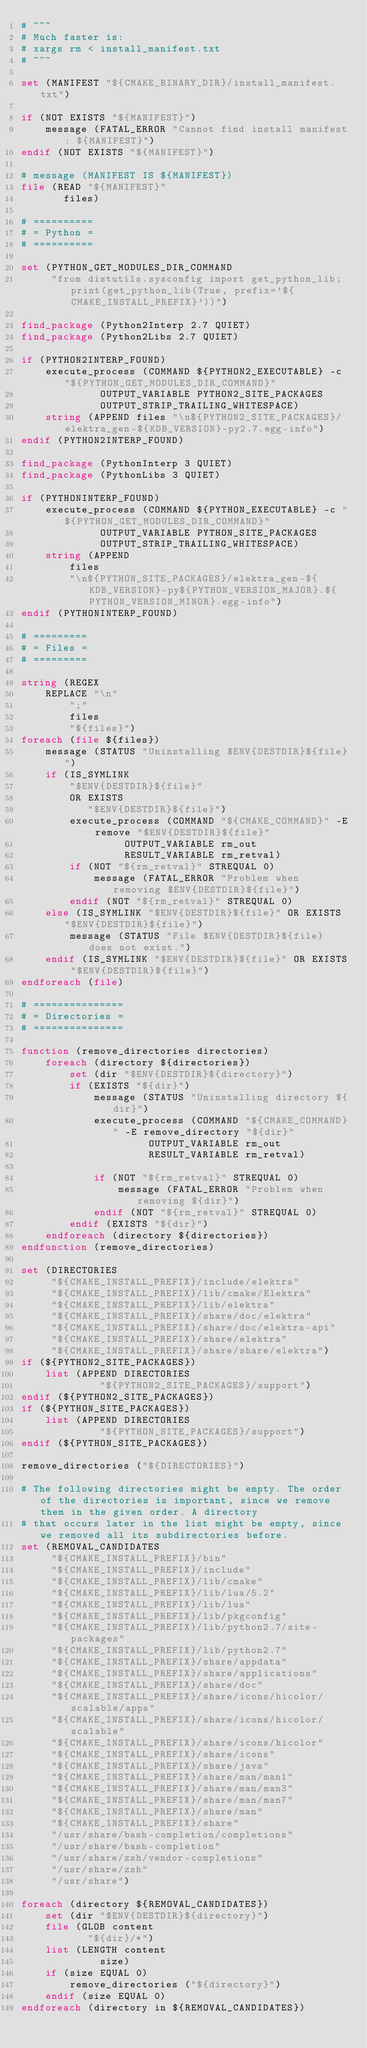<code> <loc_0><loc_0><loc_500><loc_500><_CMake_># ~~~
# Much faster is:
# xargs rm < install_manifest.txt
# ~~~

set (MANIFEST "${CMAKE_BINARY_DIR}/install_manifest.txt")

if (NOT EXISTS "${MANIFEST}")
	message (FATAL_ERROR "Cannot find install manifest: ${MANIFEST}")
endif (NOT EXISTS "${MANIFEST}")

# message (MANIFEST IS ${MANIFEST})
file (READ "${MANIFEST}"
	   files)

# ==========
# = Python =
# ==========

set (PYTHON_GET_MODULES_DIR_COMMAND
     "from distutils.sysconfig import get_python_lib; print(get_python_lib(True, prefix='${CMAKE_INSTALL_PREFIX}'))")

find_package (Python2Interp 2.7 QUIET)
find_package (Python2Libs 2.7 QUIET)

if (PYTHON2INTERP_FOUND)
	execute_process (COMMAND ${PYTHON2_EXECUTABLE} -c "${PYTHON_GET_MODULES_DIR_COMMAND}"
			 OUTPUT_VARIABLE PYTHON2_SITE_PACKAGES
			 OUTPUT_STRIP_TRAILING_WHITESPACE)
	string (APPEND files "\n${PYTHON2_SITE_PACKAGES}/elektra_gen-${KDB_VERSION}-py2.7.egg-info")
endif (PYTHON2INTERP_FOUND)

find_package (PythonInterp 3 QUIET)
find_package (PythonLibs 3 QUIET)

if (PYTHONINTERP_FOUND)
	execute_process (COMMAND ${PYTHON_EXECUTABLE} -c "${PYTHON_GET_MODULES_DIR_COMMAND}"
			 OUTPUT_VARIABLE PYTHON_SITE_PACKAGES
			 OUTPUT_STRIP_TRAILING_WHITESPACE)
	string (APPEND
		files
		"\n${PYTHON_SITE_PACKAGES}/elektra_gen-${KDB_VERSION}-py${PYTHON_VERSION_MAJOR}.${PYTHON_VERSION_MINOR}.egg-info")
endif (PYTHONINTERP_FOUND)

# =========
# = Files =
# =========

string (REGEX
	REPLACE "\n"
		";"
		files
		"${files}")
foreach (file ${files})
	message (STATUS "Uninstalling $ENV{DESTDIR}${file}")
	if (IS_SYMLINK
	    "$ENV{DESTDIR}${file}"
	    OR EXISTS
	       "$ENV{DESTDIR}${file}")
		execute_process (COMMAND "${CMAKE_COMMAND}" -E remove "$ENV{DESTDIR}${file}"
				 OUTPUT_VARIABLE rm_out
				 RESULT_VARIABLE rm_retval)
		if (NOT "${rm_retval}" STREQUAL 0)
			message (FATAL_ERROR "Problem when removing $ENV{DESTDIR}${file}")
		endif (NOT "${rm_retval}" STREQUAL 0)
	else (IS_SYMLINK "$ENV{DESTDIR}${file}" OR EXISTS "$ENV{DESTDIR}${file}")
		message (STATUS "File $ENV{DESTDIR}${file} does not exist.")
	endif (IS_SYMLINK "$ENV{DESTDIR}${file}" OR EXISTS "$ENV{DESTDIR}${file}")
endforeach (file)

# ===============
# = Directories =
# ===============

function (remove_directories directories)
	foreach (directory ${directories})
		set (dir "$ENV{DESTDIR}${directory}")
		if (EXISTS "${dir}")
			message (STATUS "Uninstalling directory ${dir}")
			execute_process (COMMAND "${CMAKE_COMMAND}" -E remove_directory "${dir}"
					 OUTPUT_VARIABLE rm_out
					 RESULT_VARIABLE rm_retval)

			if (NOT "${rm_retval}" STREQUAL 0)
				message (FATAL_ERROR "Problem when removing ${dir}")
			endif (NOT "${rm_retval}" STREQUAL 0)
		endif (EXISTS "${dir}")
	endforeach (directory ${directories})
endfunction (remove_directories)

set (DIRECTORIES
     "${CMAKE_INSTALL_PREFIX}/include/elektra"
     "${CMAKE_INSTALL_PREFIX}/lib/cmake/Elektra"
     "${CMAKE_INSTALL_PREFIX}/lib/elektra"
     "${CMAKE_INSTALL_PREFIX}/share/doc/elektra"
     "${CMAKE_INSTALL_PREFIX}/share/doc/elektra-api"
     "${CMAKE_INSTALL_PREFIX}/share/elektra"
     "${CMAKE_INSTALL_PREFIX}/share/share/elektra")
if (${PYTHON2_SITE_PACKAGES})
	list (APPEND DIRECTORIES
		     "${PYTHON2_SITE_PACKAGES}/support")
endif (${PYTHON2_SITE_PACKAGES})
if (${PYTHON_SITE_PACKAGES})
	list (APPEND DIRECTORIES
		     "${PYTHON_SITE_PACKAGES}/support")
endif (${PYTHON_SITE_PACKAGES})

remove_directories ("${DIRECTORIES}")

# The following directories might be empty. The order of the directories is important, since we remove them in the given order. A directory
# that occurs later in the list might be empty, since we removed all its subdirectories before.
set (REMOVAL_CANDIDATES
     "${CMAKE_INSTALL_PREFIX}/bin"
     "${CMAKE_INSTALL_PREFIX}/include"
     "${CMAKE_INSTALL_PREFIX}/lib/cmake"
     "${CMAKE_INSTALL_PREFIX}/lib/lua/5.2"
     "${CMAKE_INSTALL_PREFIX}/lib/lua"
     "${CMAKE_INSTALL_PREFIX}/lib/pkgconfig"
     "${CMAKE_INSTALL_PREFIX}/lib/python2.7/site-packages"
     "${CMAKE_INSTALL_PREFIX}/lib/python2.7"
     "${CMAKE_INSTALL_PREFIX}/share/appdata"
     "${CMAKE_INSTALL_PREFIX}/share/applications"
     "${CMAKE_INSTALL_PREFIX}/share/doc"
     "${CMAKE_INSTALL_PREFIX}/share/icons/hicolor/scalable/apps"
     "${CMAKE_INSTALL_PREFIX}/share/icons/hicolor/scalable"
     "${CMAKE_INSTALL_PREFIX}/share/icons/hicolor"
     "${CMAKE_INSTALL_PREFIX}/share/icons"
     "${CMAKE_INSTALL_PREFIX}/share/java"
     "${CMAKE_INSTALL_PREFIX}/share/man/man1"
     "${CMAKE_INSTALL_PREFIX}/share/man/man3"
     "${CMAKE_INSTALL_PREFIX}/share/man/man7"
     "${CMAKE_INSTALL_PREFIX}/share/man"
     "${CMAKE_INSTALL_PREFIX}/share"
     "/usr/share/bash-completion/completions"
     "/usr/share/bash-completion"
     "/usr/share/zsh/vendor-completions"
     "/usr/share/zsh"
     "/usr/share")

foreach (directory ${REMOVAL_CANDIDATES})
	set (dir "$ENV{DESTDIR}${directory}")
	file (GLOB content
		   "${dir}/*")
	list (LENGTH content
		     size)
	if (size EQUAL 0)
		remove_directories ("${directory}")
	endif (size EQUAL 0)
endforeach (directory in ${REMOVAL_CANDIDATES})
</code> 